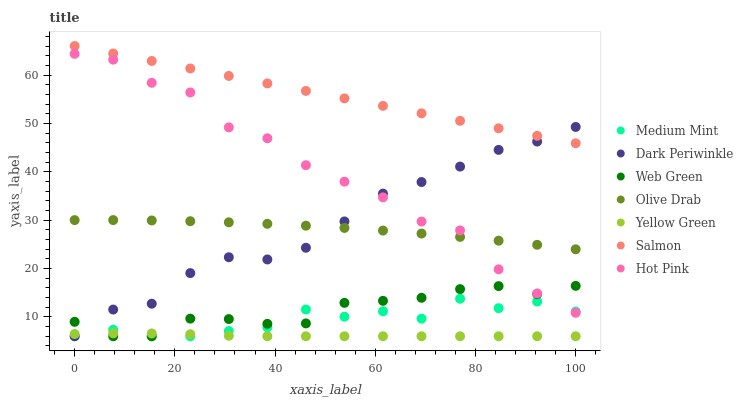Does Yellow Green have the minimum area under the curve?
Answer yes or no. Yes. Does Salmon have the maximum area under the curve?
Answer yes or no. Yes. Does Hot Pink have the minimum area under the curve?
Answer yes or no. No. Does Hot Pink have the maximum area under the curve?
Answer yes or no. No. Is Salmon the smoothest?
Answer yes or no. Yes. Is Hot Pink the roughest?
Answer yes or no. Yes. Is Yellow Green the smoothest?
Answer yes or no. No. Is Yellow Green the roughest?
Answer yes or no. No. Does Medium Mint have the lowest value?
Answer yes or no. Yes. Does Hot Pink have the lowest value?
Answer yes or no. No. Does Salmon have the highest value?
Answer yes or no. Yes. Does Hot Pink have the highest value?
Answer yes or no. No. Is Web Green less than Salmon?
Answer yes or no. Yes. Is Salmon greater than Hot Pink?
Answer yes or no. Yes. Does Dark Periwinkle intersect Web Green?
Answer yes or no. Yes. Is Dark Periwinkle less than Web Green?
Answer yes or no. No. Is Dark Periwinkle greater than Web Green?
Answer yes or no. No. Does Web Green intersect Salmon?
Answer yes or no. No. 